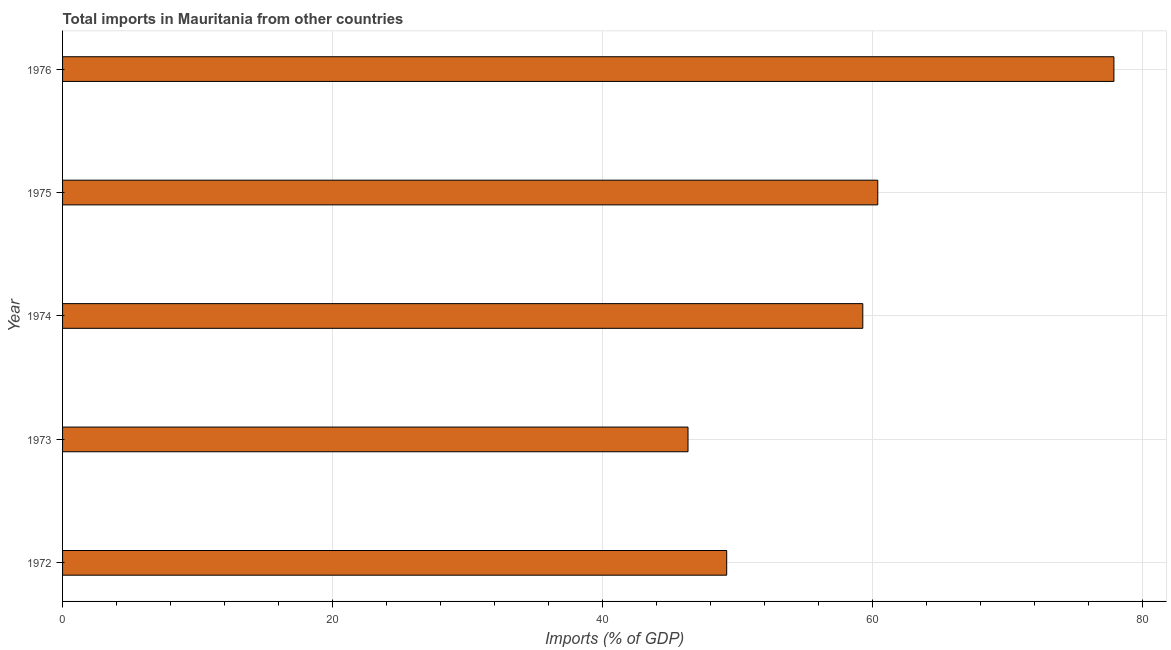Does the graph contain any zero values?
Keep it short and to the point. No. What is the title of the graph?
Offer a terse response. Total imports in Mauritania from other countries. What is the label or title of the X-axis?
Your answer should be very brief. Imports (% of GDP). What is the label or title of the Y-axis?
Offer a very short reply. Year. What is the total imports in 1972?
Provide a short and direct response. 49.21. Across all years, what is the maximum total imports?
Offer a terse response. 77.89. Across all years, what is the minimum total imports?
Your answer should be very brief. 46.34. In which year was the total imports maximum?
Make the answer very short. 1976. In which year was the total imports minimum?
Your answer should be very brief. 1973. What is the sum of the total imports?
Give a very brief answer. 293.13. What is the difference between the total imports in 1972 and 1976?
Offer a terse response. -28.69. What is the average total imports per year?
Offer a terse response. 58.62. What is the median total imports?
Provide a succinct answer. 59.29. In how many years, is the total imports greater than 76 %?
Ensure brevity in your answer.  1. What is the ratio of the total imports in 1972 to that in 1973?
Provide a succinct answer. 1.06. Is the difference between the total imports in 1972 and 1973 greater than the difference between any two years?
Keep it short and to the point. No. What is the difference between the highest and the second highest total imports?
Ensure brevity in your answer.  17.5. What is the difference between the highest and the lowest total imports?
Keep it short and to the point. 31.55. In how many years, is the total imports greater than the average total imports taken over all years?
Offer a terse response. 3. How many bars are there?
Make the answer very short. 5. Are all the bars in the graph horizontal?
Make the answer very short. Yes. What is the difference between two consecutive major ticks on the X-axis?
Your answer should be compact. 20. Are the values on the major ticks of X-axis written in scientific E-notation?
Provide a short and direct response. No. What is the Imports (% of GDP) of 1972?
Make the answer very short. 49.21. What is the Imports (% of GDP) in 1973?
Offer a very short reply. 46.34. What is the Imports (% of GDP) in 1974?
Ensure brevity in your answer.  59.29. What is the Imports (% of GDP) of 1975?
Ensure brevity in your answer.  60.4. What is the Imports (% of GDP) of 1976?
Your answer should be compact. 77.89. What is the difference between the Imports (% of GDP) in 1972 and 1973?
Your answer should be very brief. 2.87. What is the difference between the Imports (% of GDP) in 1972 and 1974?
Offer a terse response. -10.08. What is the difference between the Imports (% of GDP) in 1972 and 1975?
Give a very brief answer. -11.19. What is the difference between the Imports (% of GDP) in 1972 and 1976?
Your response must be concise. -28.69. What is the difference between the Imports (% of GDP) in 1973 and 1974?
Provide a succinct answer. -12.95. What is the difference between the Imports (% of GDP) in 1973 and 1975?
Your response must be concise. -14.06. What is the difference between the Imports (% of GDP) in 1973 and 1976?
Make the answer very short. -31.55. What is the difference between the Imports (% of GDP) in 1974 and 1975?
Give a very brief answer. -1.11. What is the difference between the Imports (% of GDP) in 1974 and 1976?
Provide a succinct answer. -18.61. What is the difference between the Imports (% of GDP) in 1975 and 1976?
Your answer should be very brief. -17.5. What is the ratio of the Imports (% of GDP) in 1972 to that in 1973?
Ensure brevity in your answer.  1.06. What is the ratio of the Imports (% of GDP) in 1972 to that in 1974?
Give a very brief answer. 0.83. What is the ratio of the Imports (% of GDP) in 1972 to that in 1975?
Keep it short and to the point. 0.81. What is the ratio of the Imports (% of GDP) in 1972 to that in 1976?
Give a very brief answer. 0.63. What is the ratio of the Imports (% of GDP) in 1973 to that in 1974?
Keep it short and to the point. 0.78. What is the ratio of the Imports (% of GDP) in 1973 to that in 1975?
Your answer should be compact. 0.77. What is the ratio of the Imports (% of GDP) in 1973 to that in 1976?
Your answer should be compact. 0.59. What is the ratio of the Imports (% of GDP) in 1974 to that in 1975?
Make the answer very short. 0.98. What is the ratio of the Imports (% of GDP) in 1974 to that in 1976?
Make the answer very short. 0.76. What is the ratio of the Imports (% of GDP) in 1975 to that in 1976?
Provide a short and direct response. 0.78. 